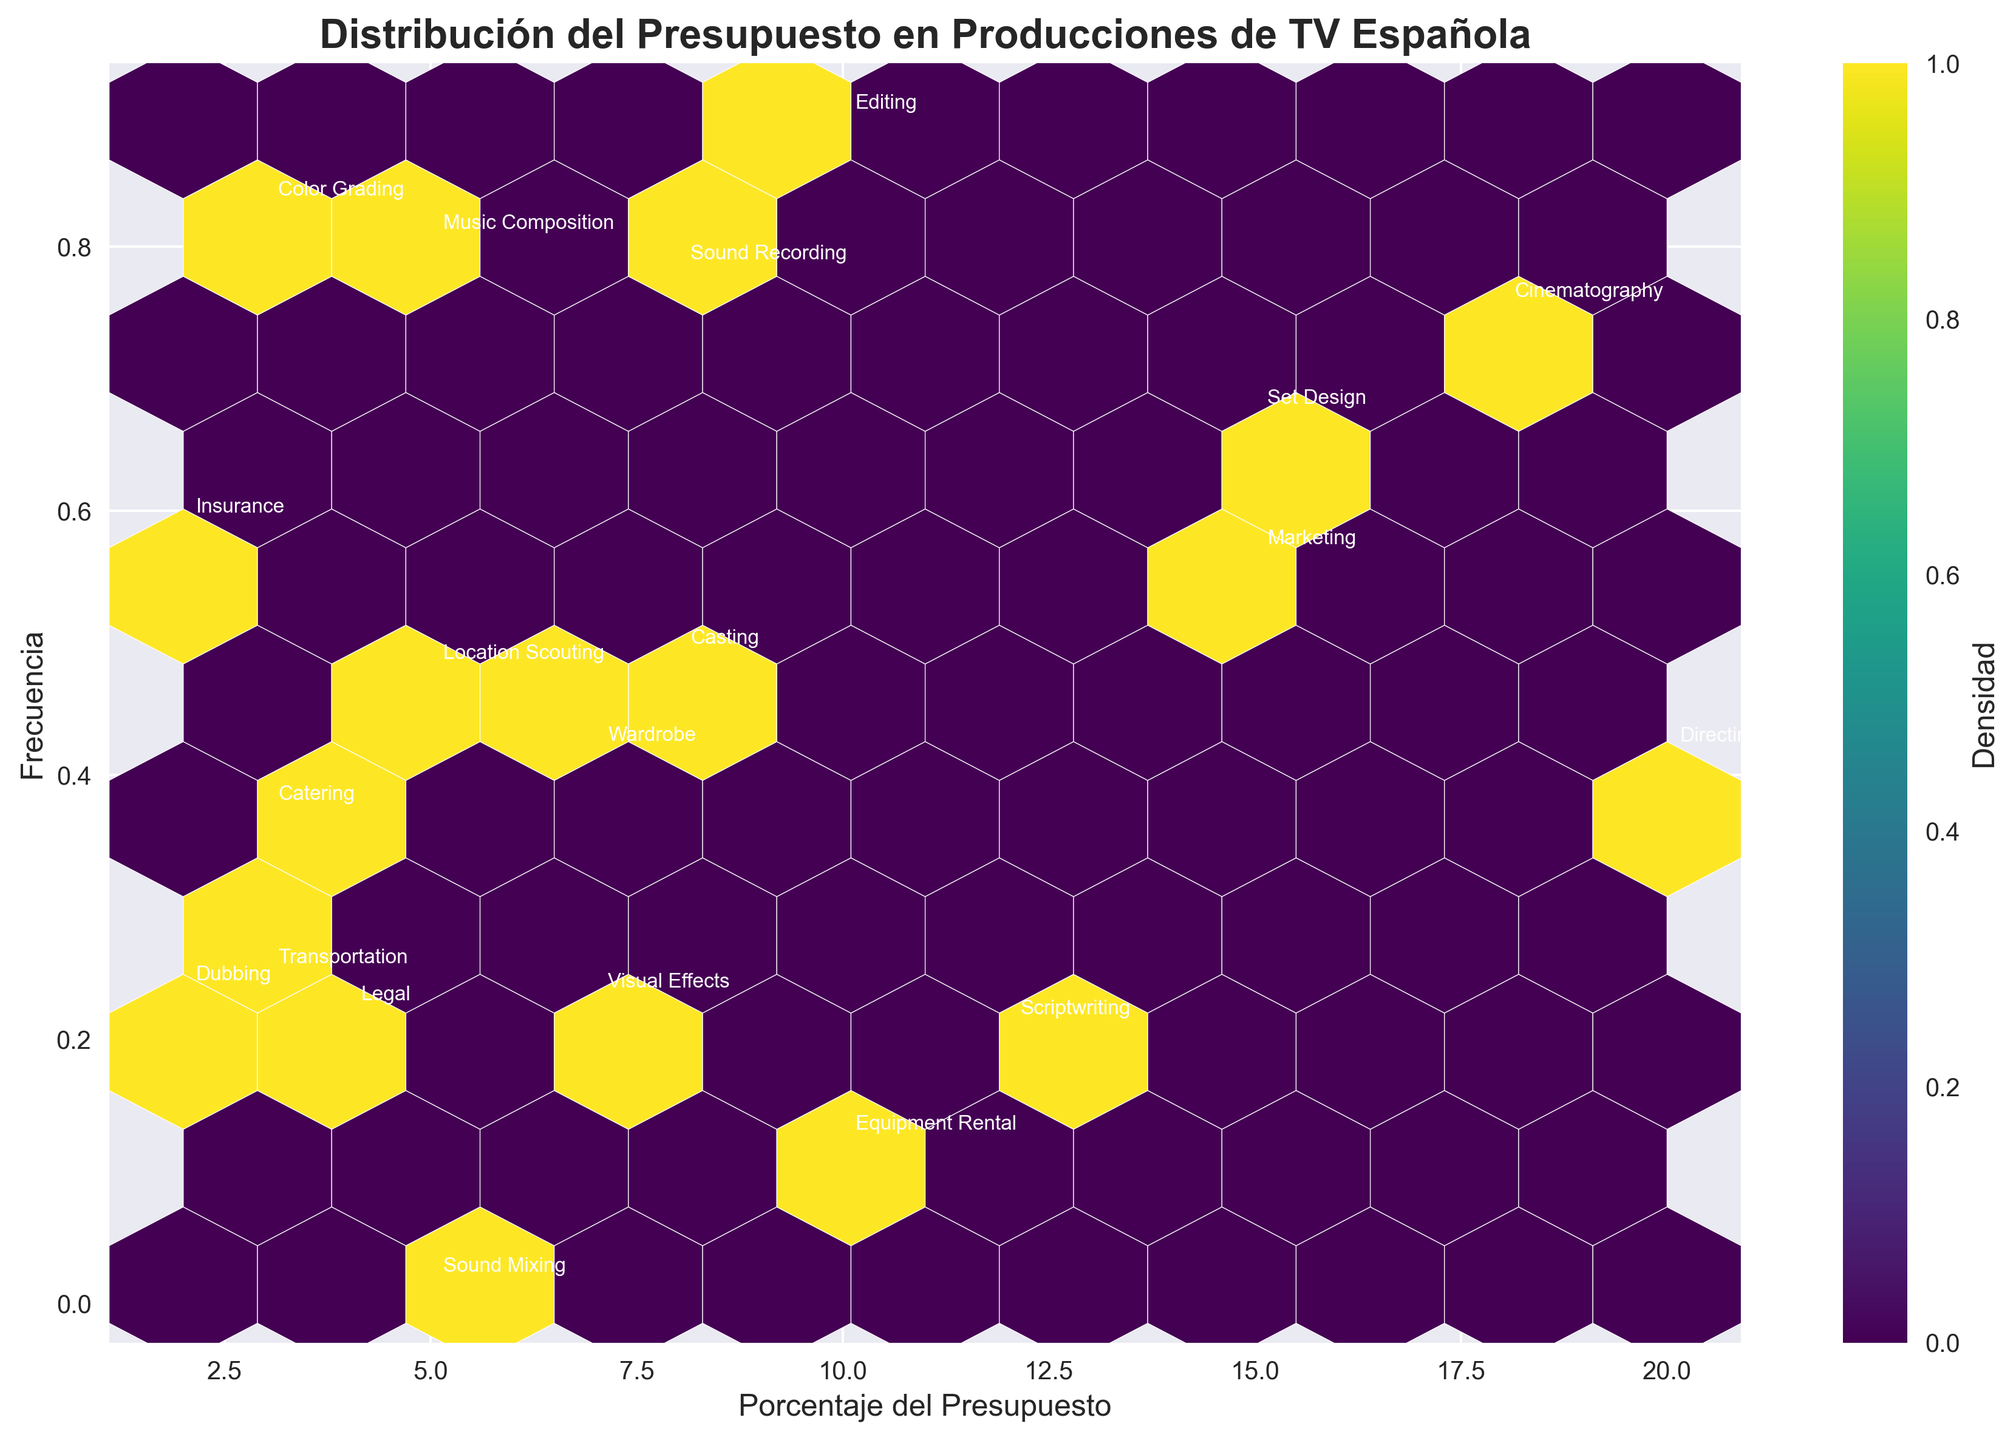What's the title of the hexbin plot? The title of a plot is generally placed at the top. In this plot, the title states the main subject of the figure.
Answer: Distribución del Presupuesto en Producciones de TV Española What does the x-axis represent? The x-axis label describes what is being measured horizontally. In this plot, it shows how the budget is distributed among different percentages.
Answer: Porcentaje del Presupuesto What does the y-axis represent? The y-axis label explains what is measured vertically. In this hexbin plot, y-axis values are randomly generated to show the frequency distribution of budget percentages visually.
Answer: Frecuencia Which department has the highest budget percentage? By annotating the hexbin plot, each department's budget percentage is indicated. The department with the highest labeled percentage (20%) is identified.
Answer: Directing How many departments fall within the 2%-5% budget range? Observing the plot annotations, count the number of departments that have budget percentages between 2% and 5%.
Answer: 7 departments (Legal, Insurance, Catering, Transportation, Color Grading, Sound Mixing, Dubbing) Is there a department with a budget percentage exactly mid-range of the possible percentages (from 0-20%)? The midpoint of the possible range (0% to 20%) is 10%. Identify any department annotated with a 10% budget.
Answer: Editing Which department's budget percentage falls closest to 15%? Locate annotations near the 15% mark and identify the department whose budget is labeled as 15%.
Answer: Set Design What is the combined budget percentage for Scriptwriting and Wardrobe? Add the budget percentages of Scriptwriting (12%) and Wardrobe (7%).
Answer: 19% Which department's budget percentage is higher, Marketing or Visual Effects? Compare the annotated budget percentages for Marketing (15%) and Visual Effects (7%).
Answer: Marketing 